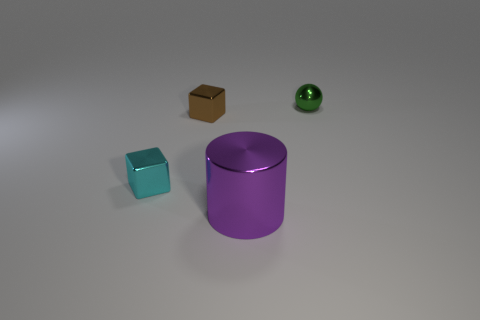What could be the purpose of this arrangement? This arrangement might be part of a study or exhibit that focuses on geometry and material properties. The objects could have been arranged to demonstrate contrasts in shape, size, and texture, or possibly for a visual composition exercise in photography or 3D modeling. 